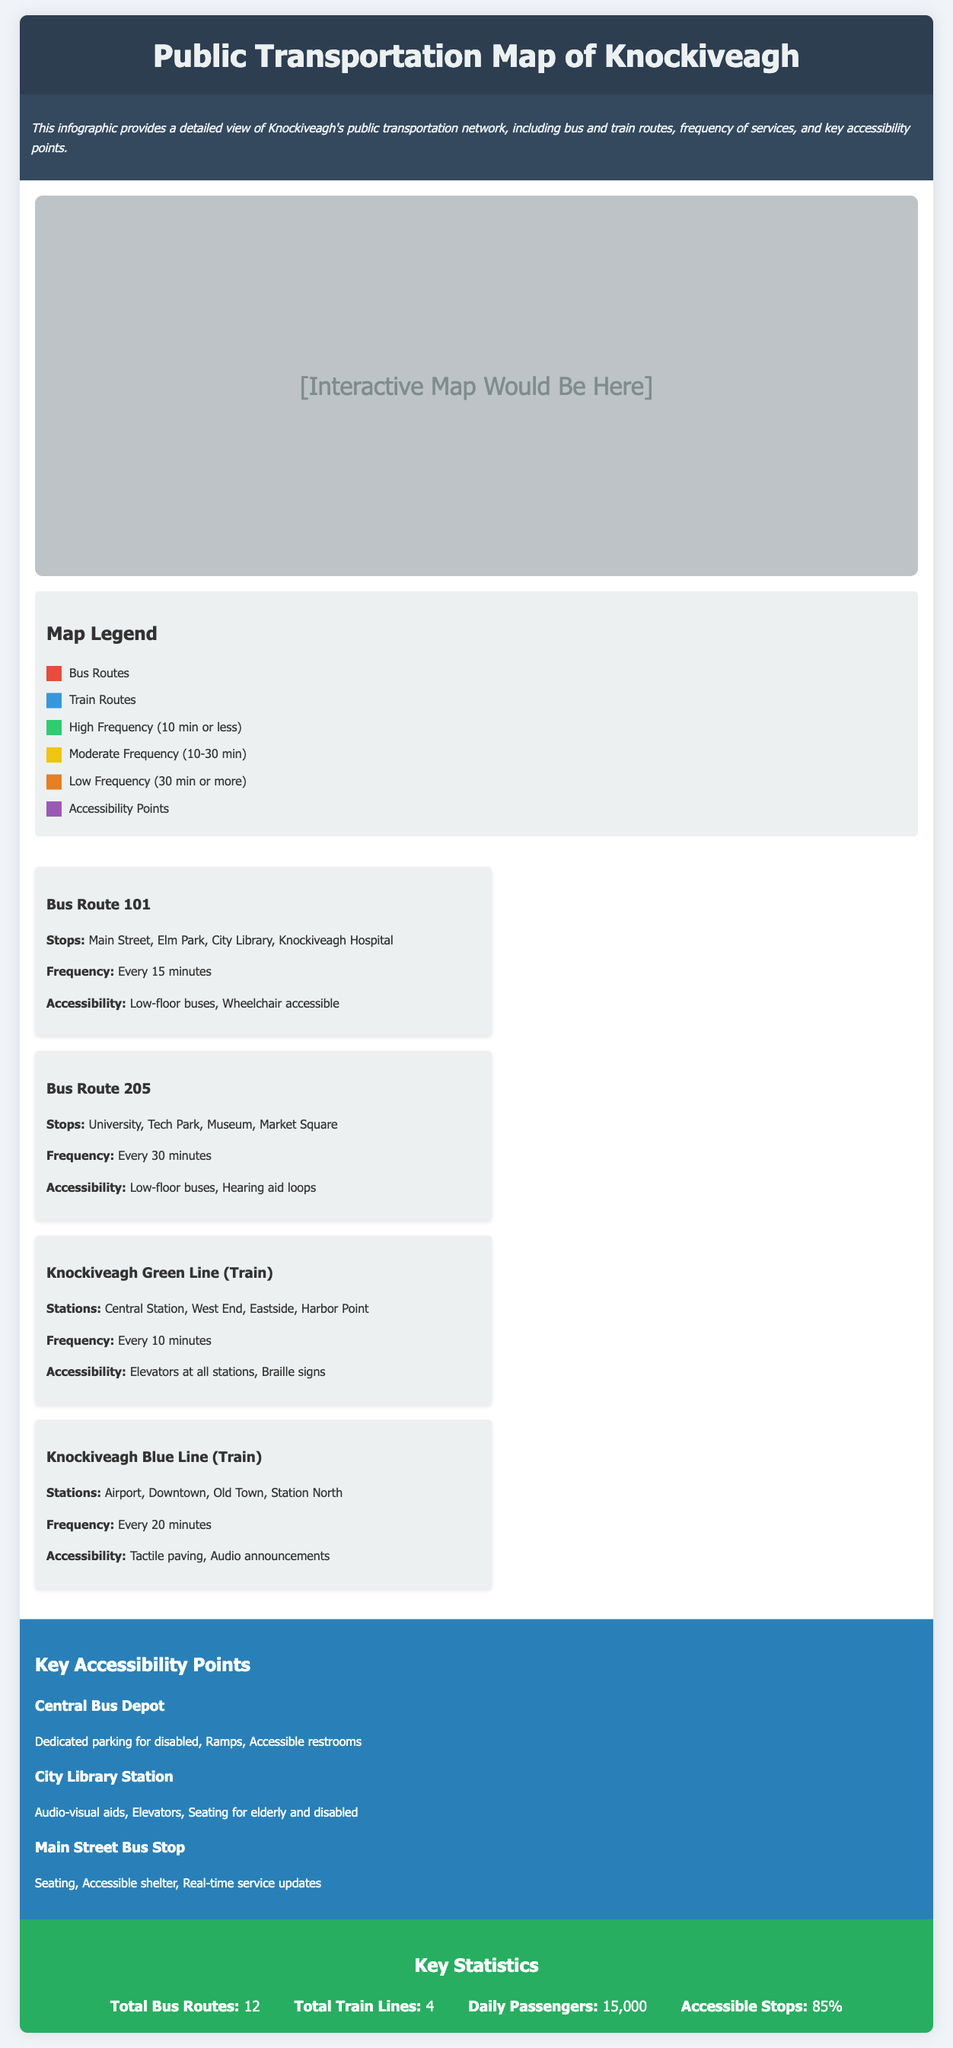What is the title of the infographic? The title of the infographic is provided in the header section of the document.
Answer: Public Transportation Map of Knockiveagh How many total bus routes are listed? The number of total bus routes can be found in the key statistics section.
Answer: 12 What is the frequency of the Knockiveagh Green Line (Train)? The frequency of this train route is specified in its route information section.
Answer: Every 10 minutes What accessibility feature is available at all stations on the Knockiveagh Green Line? The accessibility features of this train route are outlined in its route information section, focusing on what is available at the stations.
Answer: Elevators at all stations Which bus route has a frequency of every 30 minutes? The specific bus route with this frequency is detailed in the route information.
Answer: Bus Route 205 Which location has dedicated parking for the disabled? The location with this accessibility feature is listed under key accessibility points.
Answer: Central Bus Depot How many daily passengers utilize the public transportation system? The number of daily passengers is provided in the key statistics section of the document.
Answer: 15,000 What color represents bus routes on the map? The color representing bus routes is outlined in the map legend.
Answer: Red 